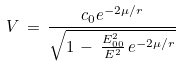<formula> <loc_0><loc_0><loc_500><loc_500>V \, = \, \frac { c _ { 0 } e ^ { - 2 \mu / r } } { \sqrt { 1 \, - \, \frac { E _ { 0 0 } ^ { 2 } } { E ^ { 2 } } \, e ^ { - 2 \mu / r } } }</formula> 